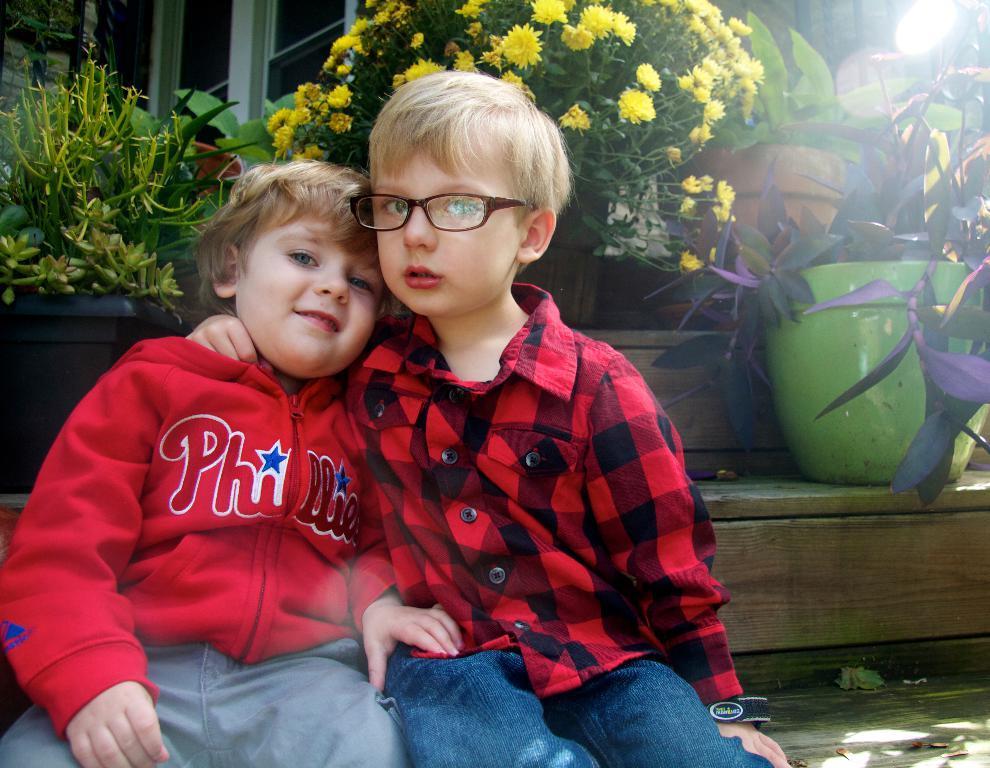Describe this image in one or two sentences. In this image we can see kids sitting on the stairs. In the background there are different kinds of plants in the pots. 